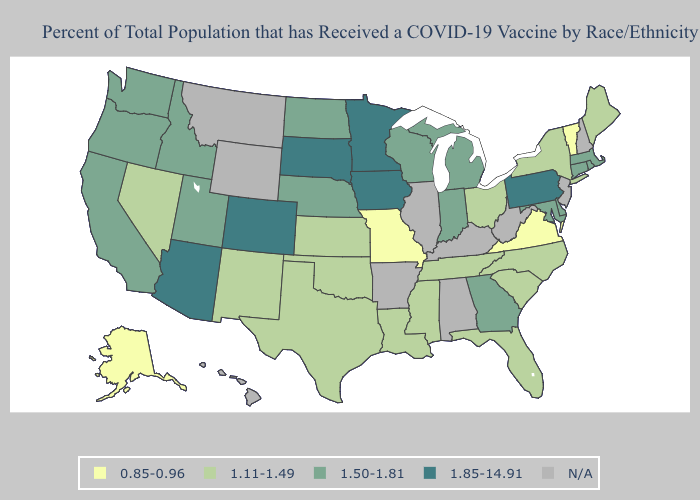What is the lowest value in the USA?
Write a very short answer. 0.85-0.96. Among the states that border Missouri , does Tennessee have the highest value?
Answer briefly. No. What is the lowest value in the South?
Quick response, please. 0.85-0.96. What is the highest value in states that border Wyoming?
Quick response, please. 1.85-14.91. Name the states that have a value in the range 1.11-1.49?
Write a very short answer. Florida, Kansas, Louisiana, Maine, Mississippi, Nevada, New Mexico, New York, North Carolina, Ohio, Oklahoma, South Carolina, Tennessee, Texas. What is the value of New Hampshire?
Quick response, please. N/A. What is the value of Rhode Island?
Give a very brief answer. 1.50-1.81. Does Colorado have the highest value in the USA?
Keep it brief. Yes. Which states have the highest value in the USA?
Give a very brief answer. Arizona, Colorado, Iowa, Minnesota, Pennsylvania, South Dakota. Name the states that have a value in the range 0.85-0.96?
Answer briefly. Alaska, Missouri, Vermont, Virginia. Among the states that border Kentucky , which have the highest value?
Concise answer only. Indiana. Name the states that have a value in the range 0.85-0.96?
Answer briefly. Alaska, Missouri, Vermont, Virginia. Which states hav the highest value in the West?
Short answer required. Arizona, Colorado. Does New York have the highest value in the Northeast?
Write a very short answer. No. 